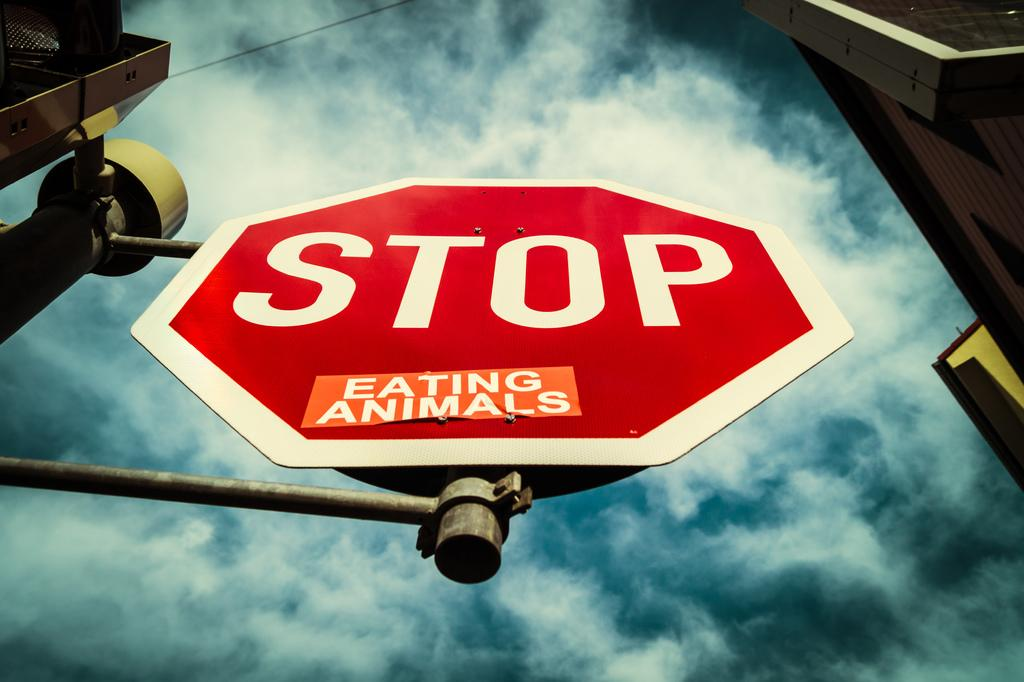<image>
Describe the image concisely. a stop sign that also says to stop eating animals. 